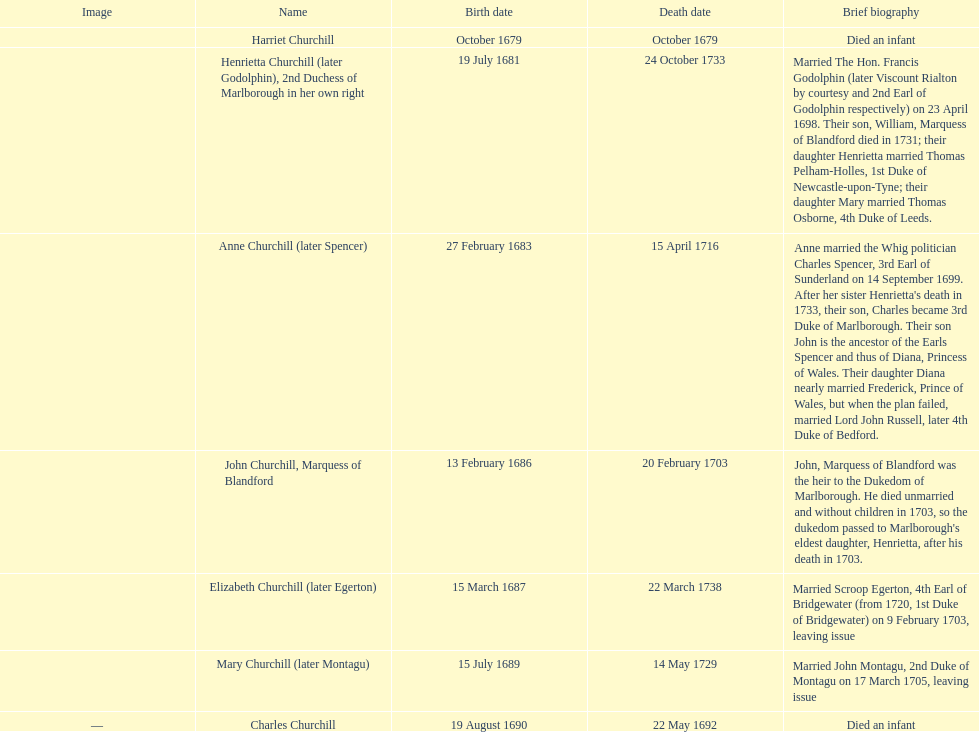Who was born first? mary churchill or elizabeth churchill? Elizabeth Churchill. 